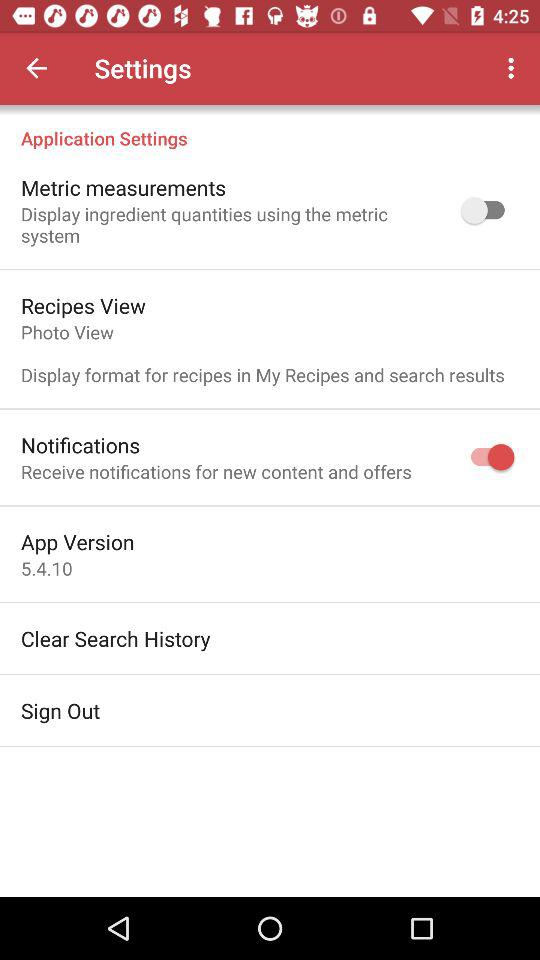How many items have a switch?
Answer the question using a single word or phrase. 2 